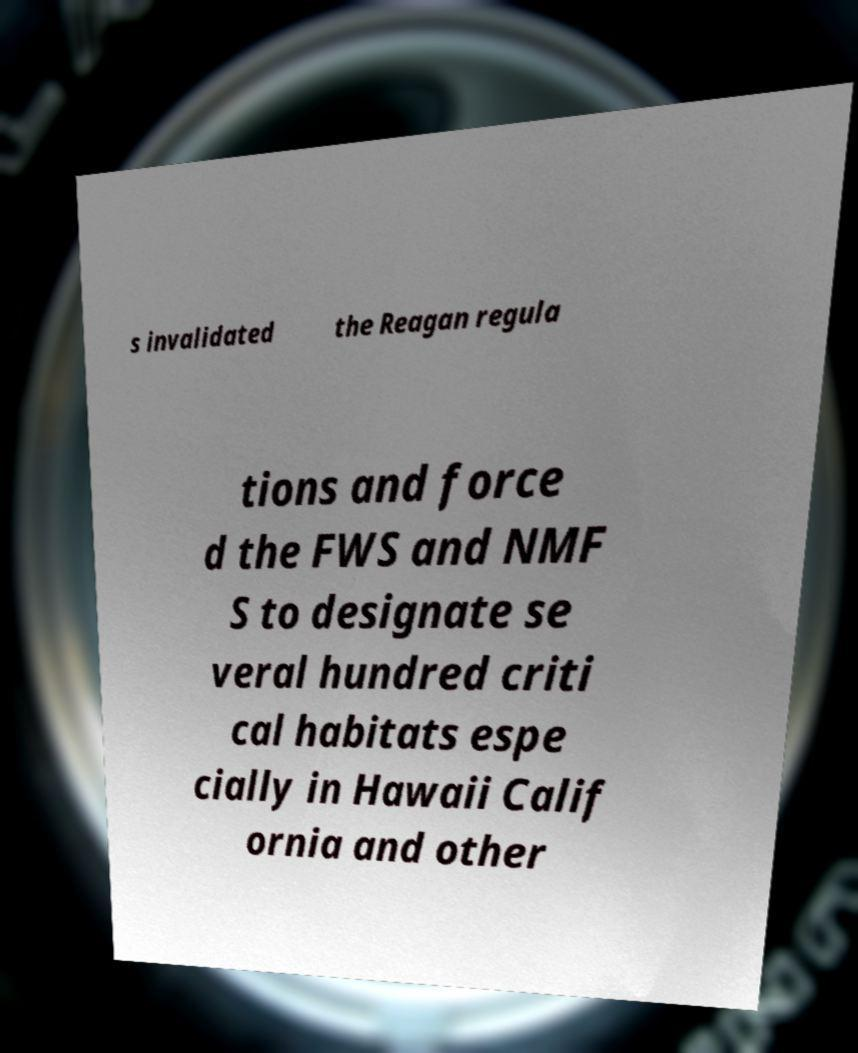Please read and relay the text visible in this image. What does it say? s invalidated the Reagan regula tions and force d the FWS and NMF S to designate se veral hundred criti cal habitats espe cially in Hawaii Calif ornia and other 